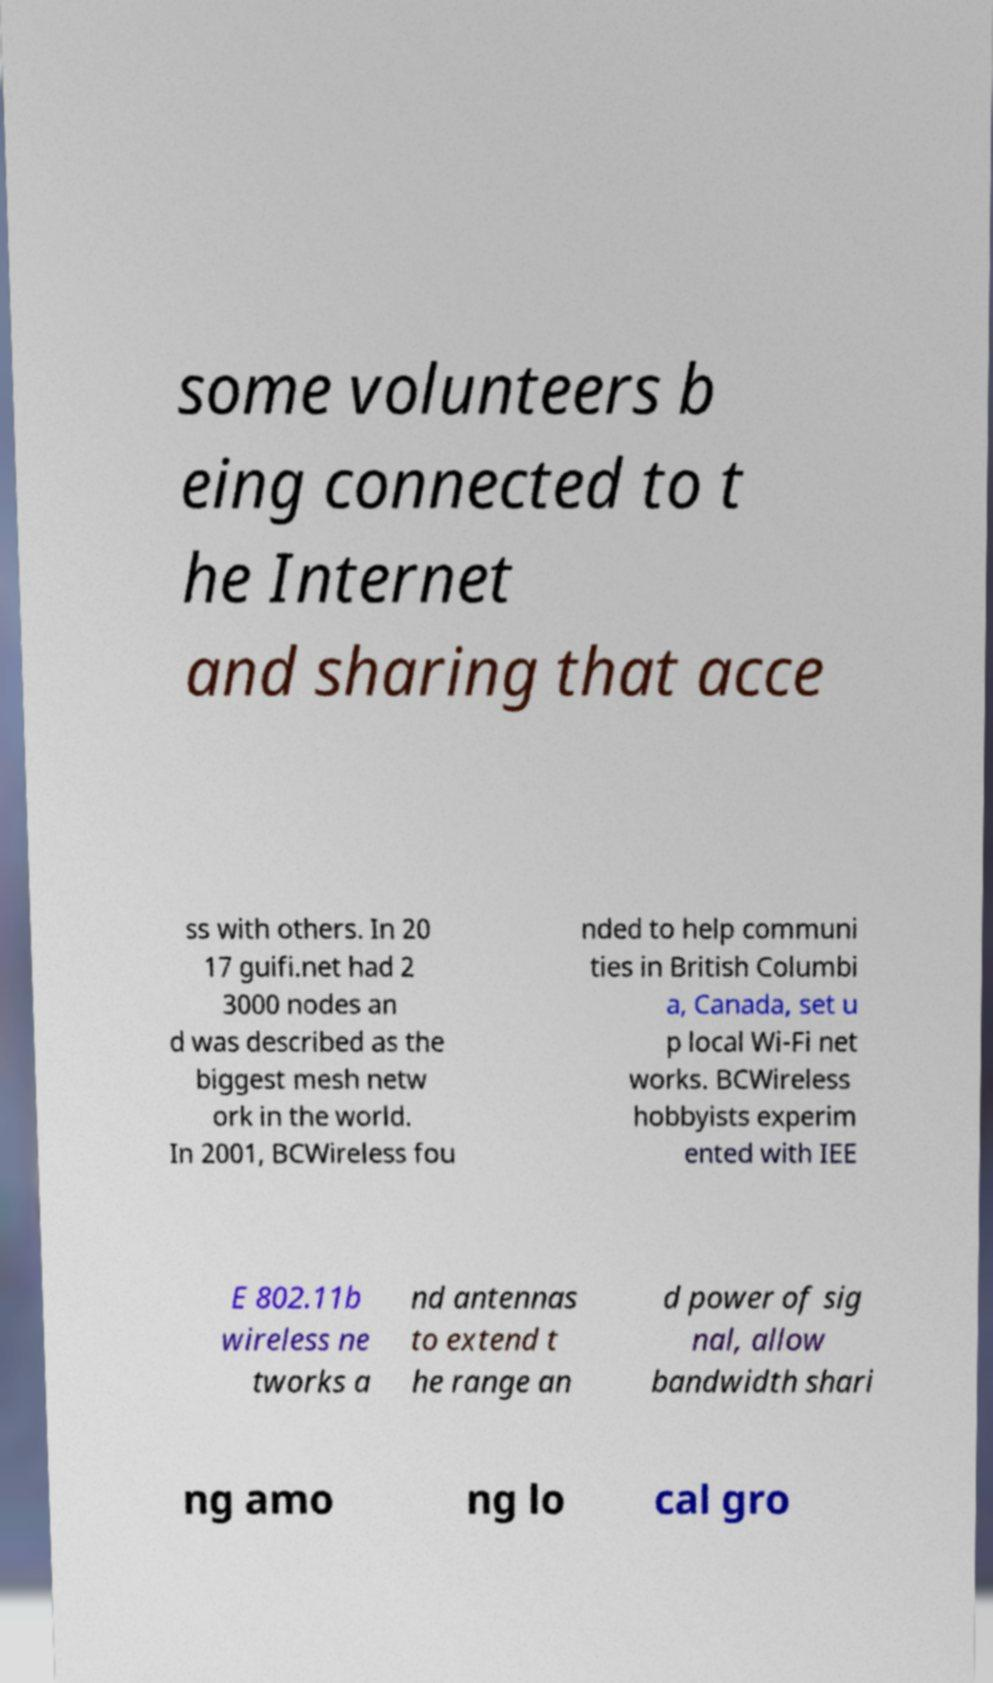For documentation purposes, I need the text within this image transcribed. Could you provide that? some volunteers b eing connected to t he Internet and sharing that acce ss with others. In 20 17 guifi.net had 2 3000 nodes an d was described as the biggest mesh netw ork in the world. In 2001, BCWireless fou nded to help communi ties in British Columbi a, Canada, set u p local Wi-Fi net works. BCWireless hobbyists experim ented with IEE E 802.11b wireless ne tworks a nd antennas to extend t he range an d power of sig nal, allow bandwidth shari ng amo ng lo cal gro 